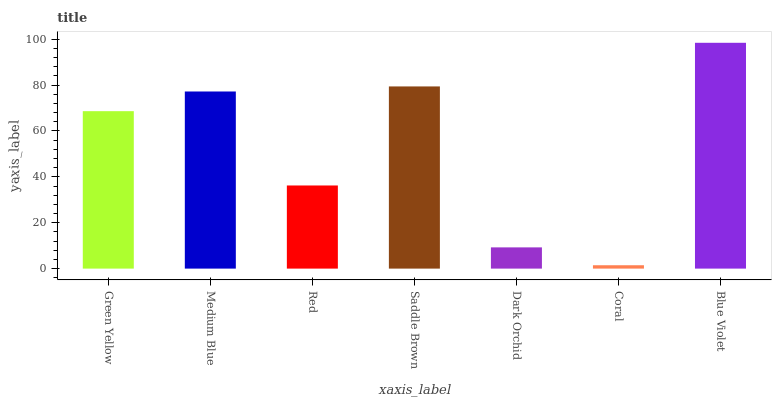Is Coral the minimum?
Answer yes or no. Yes. Is Blue Violet the maximum?
Answer yes or no. Yes. Is Medium Blue the minimum?
Answer yes or no. No. Is Medium Blue the maximum?
Answer yes or no. No. Is Medium Blue greater than Green Yellow?
Answer yes or no. Yes. Is Green Yellow less than Medium Blue?
Answer yes or no. Yes. Is Green Yellow greater than Medium Blue?
Answer yes or no. No. Is Medium Blue less than Green Yellow?
Answer yes or no. No. Is Green Yellow the high median?
Answer yes or no. Yes. Is Green Yellow the low median?
Answer yes or no. Yes. Is Saddle Brown the high median?
Answer yes or no. No. Is Saddle Brown the low median?
Answer yes or no. No. 